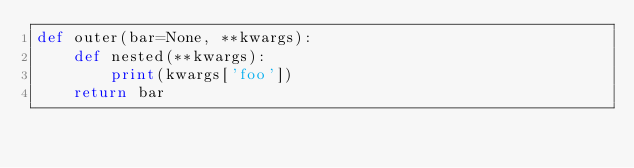Convert code to text. <code><loc_0><loc_0><loc_500><loc_500><_Python_>def outer(bar=None, **kwargs):
    def nested(**kwargs):
        print(kwargs['foo'])
    return bar</code> 